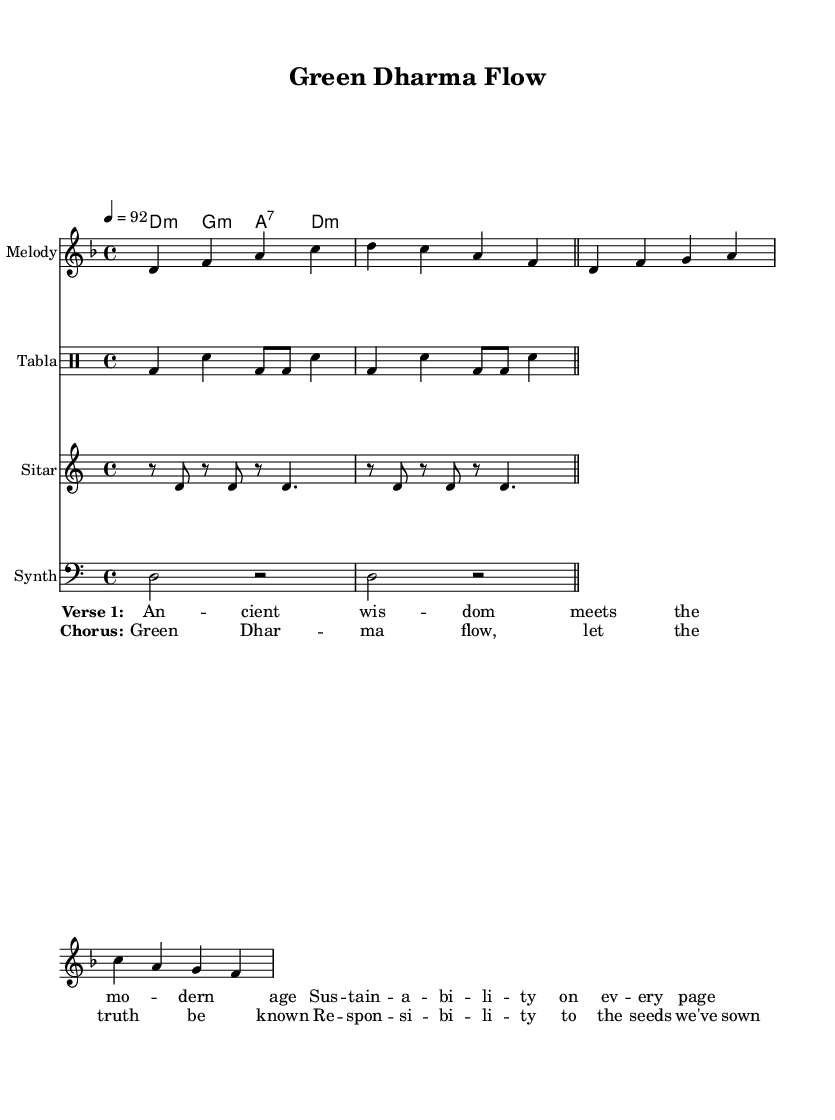What is the key signature of this music? The key signature is D minor, indicated by one flat. This can be identified by looking at the key signature section at the beginning of the staff.
Answer: D minor What is the time signature of this music? The time signature is 4/4, which can be found at the beginning of the score. It shows that each measure contains four beats, and the quarter note gets one beat.
Answer: 4/4 What is the tempo marking in the piece? The tempo marking is 92 beats per minute, located in the global settings at the beginning of the sheet music. This indicates the speed at which the piece should be played.
Answer: 92 How many measures are in the melody section? The melody section contains 5 measures, which can be determined by counting the bar lines that separate the measures. Measures are indicated by vertical lines across the staff.
Answer: 5 What is the primary theme expressed in the lyrics? The primary theme expressed in the lyrics revolves around ancient wisdom and modern sustainability, highlighted in the first verse, promoting responsibility to maintain the environment.
Answer: Sustainability What instrument is used for the rhythm section? The rhythm section uses the tabla, as indicated in the Instrument names for that particular staff line in the music sheet. The tabla is a traditional Indian percussion instrument, aligning with the cultural theme.
Answer: Tabla What is the purpose of the chorus in this rap piece? The chorus serves to emphasize the central message of the song, which focuses on "Green Dharma flow" and the idea of accountability for environmental actions taken, unifying the verses with a memorable refrain.
Answer: Accountability 